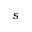Convert formula to latex. <formula><loc_0><loc_0><loc_500><loc_500>s</formula> 